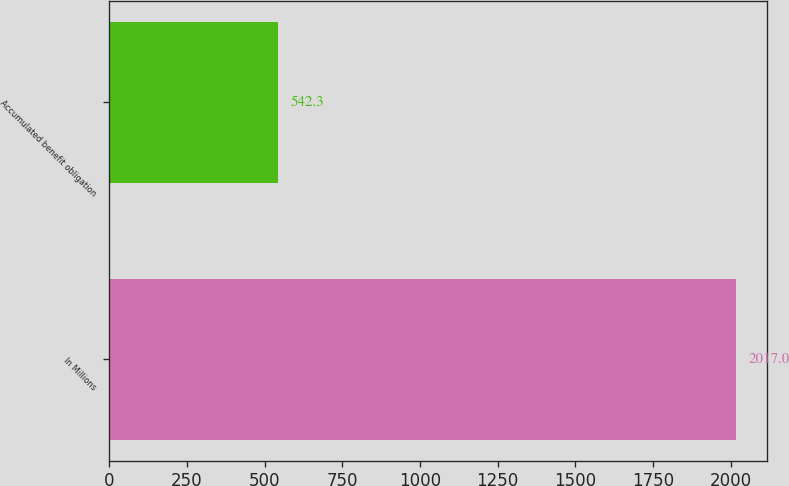<chart> <loc_0><loc_0><loc_500><loc_500><bar_chart><fcel>In Millions<fcel>Accumulated benefit obligation<nl><fcel>2017<fcel>542.3<nl></chart> 